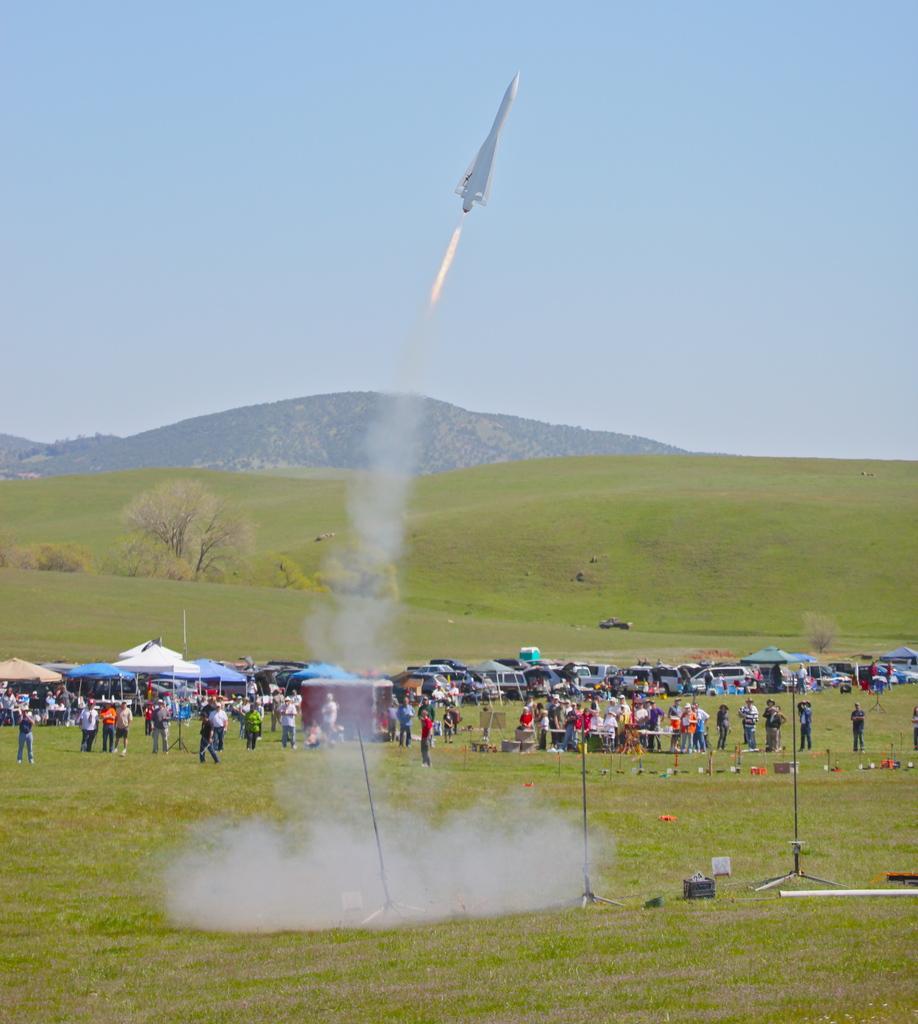Could you give a brief overview of what you see in this image? This is an outside view. I can see the grass on the ground. Here I can see a crowd of people standing on the ground and also so there are many vehicles. In the background there is a hill. At the top of the image there is a rocket flying in the air and also I can see the sky. 